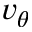Convert formula to latex. <formula><loc_0><loc_0><loc_500><loc_500>v _ { \theta }</formula> 